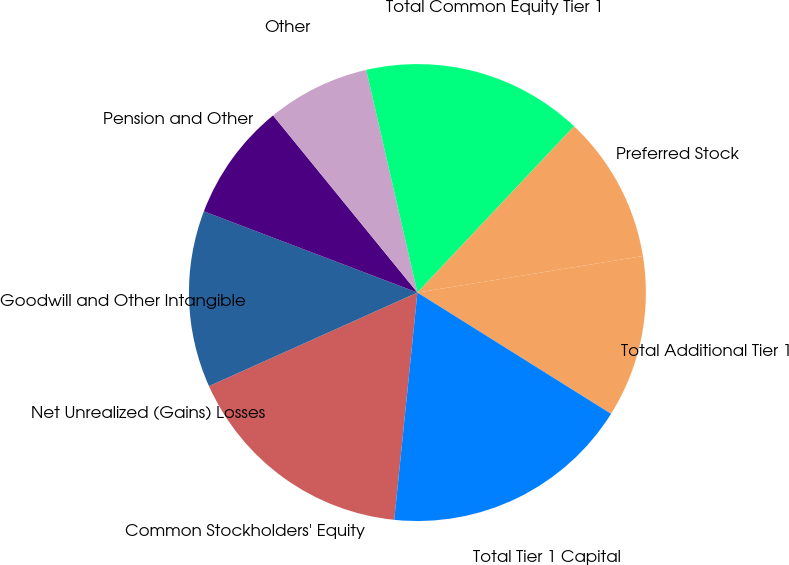Convert chart to OTSL. <chart><loc_0><loc_0><loc_500><loc_500><pie_chart><fcel>Common Stockholders' Equity<fcel>Net Unrealized (Gains) Losses<fcel>Goodwill and Other Intangible<fcel>Pension and Other<fcel>Other<fcel>Total Common Equity Tier 1<fcel>Preferred Stock<fcel>Total Additional Tier 1<fcel>Total Tier 1 Capital<nl><fcel>16.67%<fcel>0.0%<fcel>12.5%<fcel>8.33%<fcel>7.29%<fcel>15.62%<fcel>10.42%<fcel>11.46%<fcel>17.71%<nl></chart> 